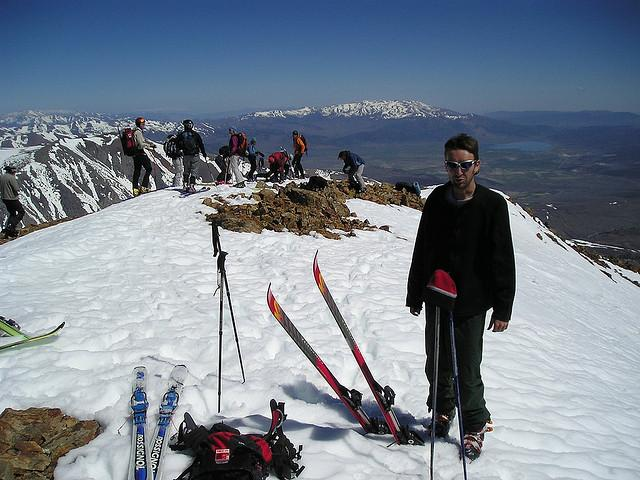How will everyone get off the top of the mountain? Please explain your reasoning. ski. People will ski with the poles. 